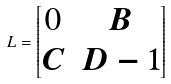Convert formula to latex. <formula><loc_0><loc_0><loc_500><loc_500>L = \begin{bmatrix} 0 & B \\ C & D - 1 \end{bmatrix}</formula> 